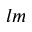<formula> <loc_0><loc_0><loc_500><loc_500>l m</formula> 